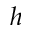<formula> <loc_0><loc_0><loc_500><loc_500>h</formula> 